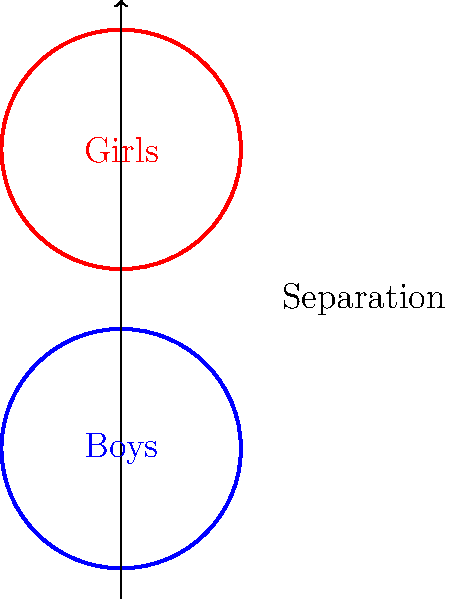In a traditional school setting, how does the separation of boys and girls into distinct educational spaces, as illustrated by the non-intersecting circles, potentially impact the learning environment? Consider the implications for social development and academic focus. To answer this question, let's consider the following steps:

1. Physical separation: The diagram shows two non-intersecting circles, representing separate spaces for boys and girls.

2. Reduced distractions: Separating genders can potentially reduce romantic distractions, allowing students to focus more on academics.

3. Tailored teaching: Gender-specific classrooms may allow for teaching methods that cater to perceived differences in learning styles between boys and girls.

4. Social development: Limited interaction between genders during school hours may impact students' ability to develop healthy cross-gender relationships and communication skills.

5. Traditional values: This separation aligns with conservative views on maintaining distinct gender roles and minimizing potentially inappropriate interactions.

6. Academic performance: Some studies suggest that single-sex classrooms can lead to improved academic performance, especially in subjects where one gender traditionally underperforms.

7. Stereotypes: Separation may reinforce gender stereotypes and limit exposure to diverse perspectives.

8. Preparation for real-world interactions: Students may be less prepared for mixed-gender environments in higher education and the workforce.

The impact of gender separation in schools is a complex issue with both potential benefits and drawbacks, depending on one's educational philosophy and societal values.
Answer: Promotes focus and traditional values; may limit social development and reinforce stereotypes. 